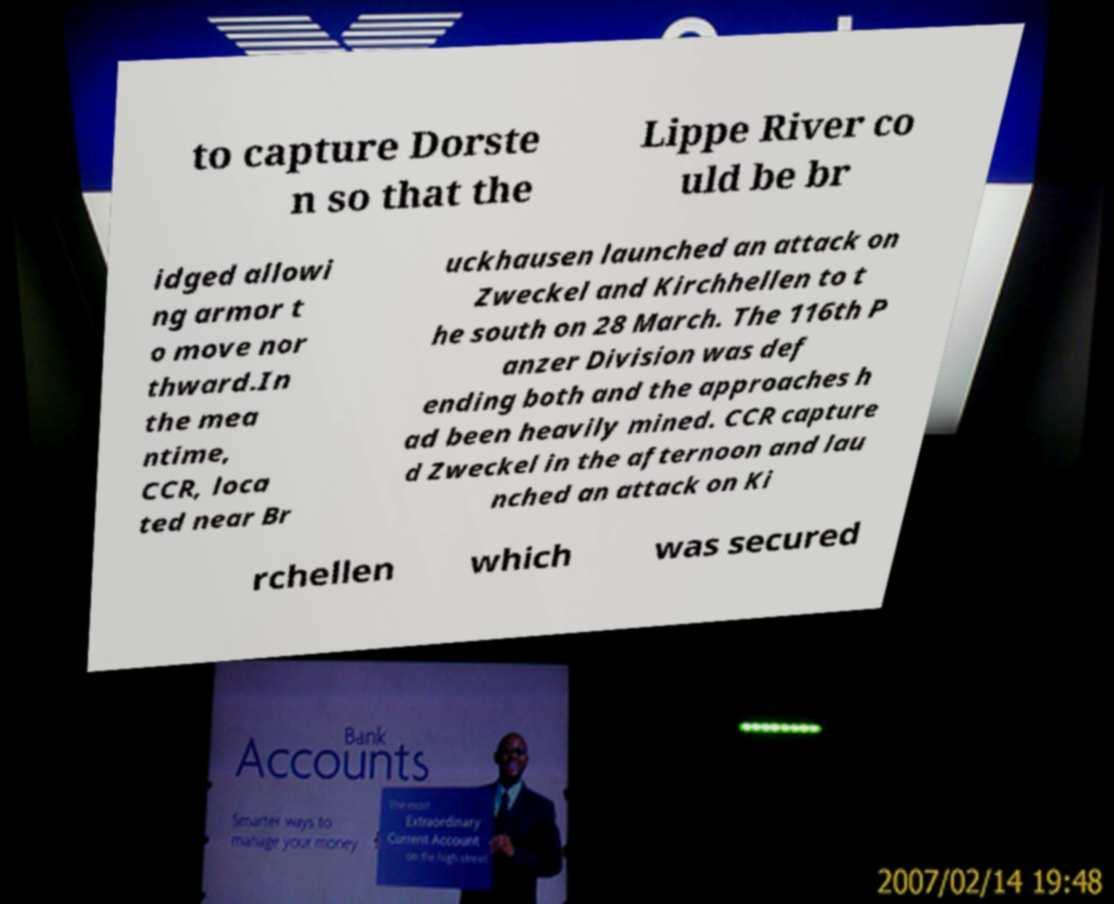Could you extract and type out the text from this image? to capture Dorste n so that the Lippe River co uld be br idged allowi ng armor t o move nor thward.In the mea ntime, CCR, loca ted near Br uckhausen launched an attack on Zweckel and Kirchhellen to t he south on 28 March. The 116th P anzer Division was def ending both and the approaches h ad been heavily mined. CCR capture d Zweckel in the afternoon and lau nched an attack on Ki rchellen which was secured 